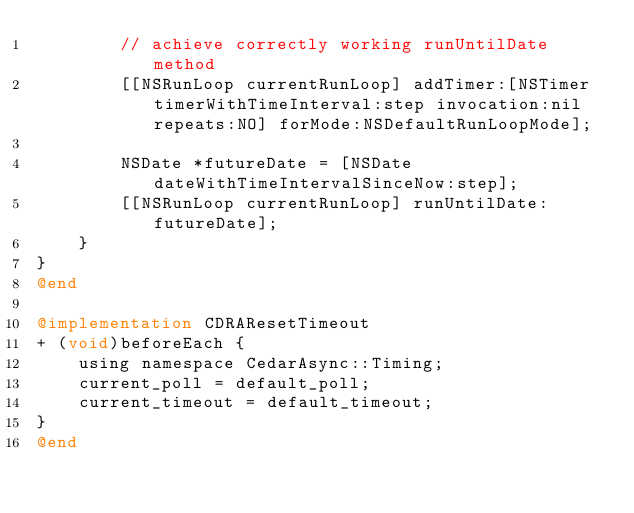Convert code to text. <code><loc_0><loc_0><loc_500><loc_500><_ObjectiveC_>        // achieve correctly working runUntilDate method
        [[NSRunLoop currentRunLoop] addTimer:[NSTimer timerWithTimeInterval:step invocation:nil repeats:NO] forMode:NSDefaultRunLoopMode];
        
        NSDate *futureDate = [NSDate dateWithTimeIntervalSinceNow:step];
        [[NSRunLoop currentRunLoop] runUntilDate:futureDate];
    }
}
@end

@implementation CDRAResetTimeout
+ (void)beforeEach {
    using namespace CedarAsync::Timing;
    current_poll = default_poll;
    current_timeout = default_timeout;
}
@end
</code> 